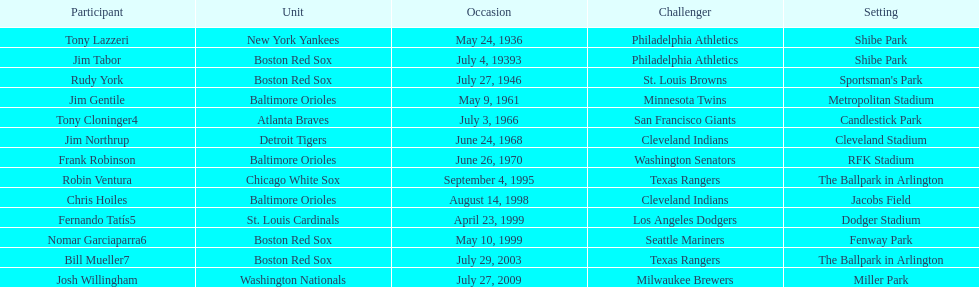What was the name of the last person to accomplish this up to date? Josh Willingham. 